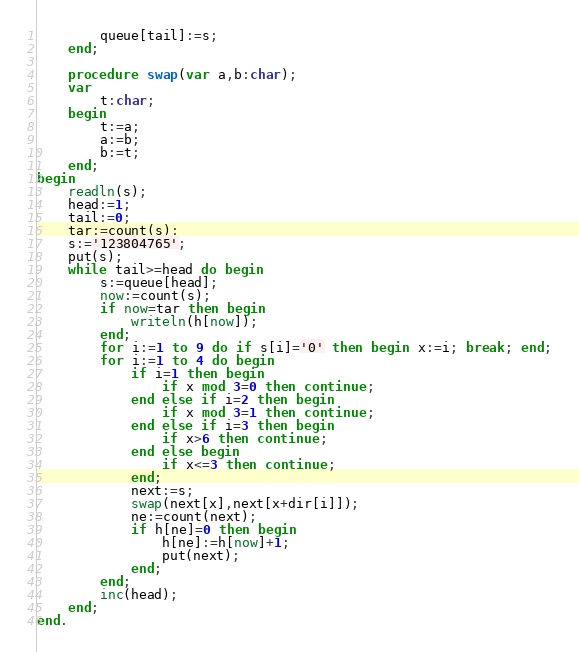<code> <loc_0><loc_0><loc_500><loc_500><_Pascal_>		queue[tail]:=s;
	end;
	
	procedure swap(var a,b:char);
	var
		t:char;
	begin
		t:=a;
		a:=b;
		b:=t;
	end;
begin
	readln(s);
	head:=1;
	tail:=0;
	tar:=count(s);
	s:='123804765';
	put(s);
	while tail>=head do begin
		s:=queue[head];
		now:=count(s);
		if now=tar then begin
			writeln(h[now]);
		end;
		for i:=1 to 9 do if s[i]='0' then begin x:=i; break; end;
		for i:=1 to 4 do begin
			if i=1 then begin
				if x mod 3=0 then continue;
			end else if i=2 then begin
				if x mod 3=1 then continue;
			end else if i=3 then begin
				if x>6 then continue;
			end else begin
				if x<=3 then continue;
			end;
			next:=s;
			swap(next[x],next[x+dir[i]]);
			ne:=count(next);
			if h[ne]=0 then begin
				h[ne]:=h[now]+1;
				put(next);
			end;
		end;
		inc(head);
	end;
end.</code> 